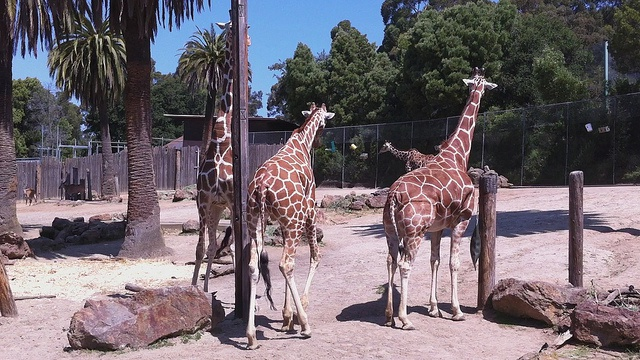Describe the objects in this image and their specific colors. I can see giraffe in black, lightgray, brown, pink, and darkgray tones, giraffe in black, brown, lightgray, and lightpink tones, giraffe in black, gray, and lightgray tones, and giraffe in black, gray, and darkgray tones in this image. 